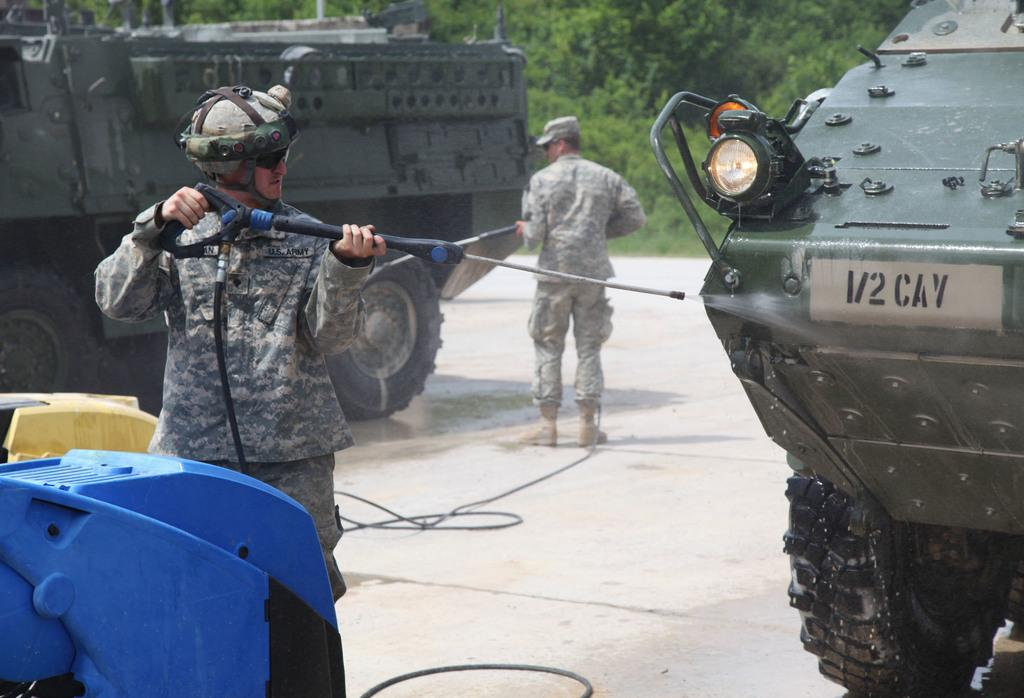Who or what is present in the image? There is a person in the image. What is the person holding? The person is holding a pipe. What type of natural environment is visible in the image? There are trees in the image. How many people are present in the image? There are people in the image. What else can be seen in the image besides the person and trees? There are vehicles in the image. What type of cheese is being used to build the animal in the image? There is no cheese or animal present in the image. 